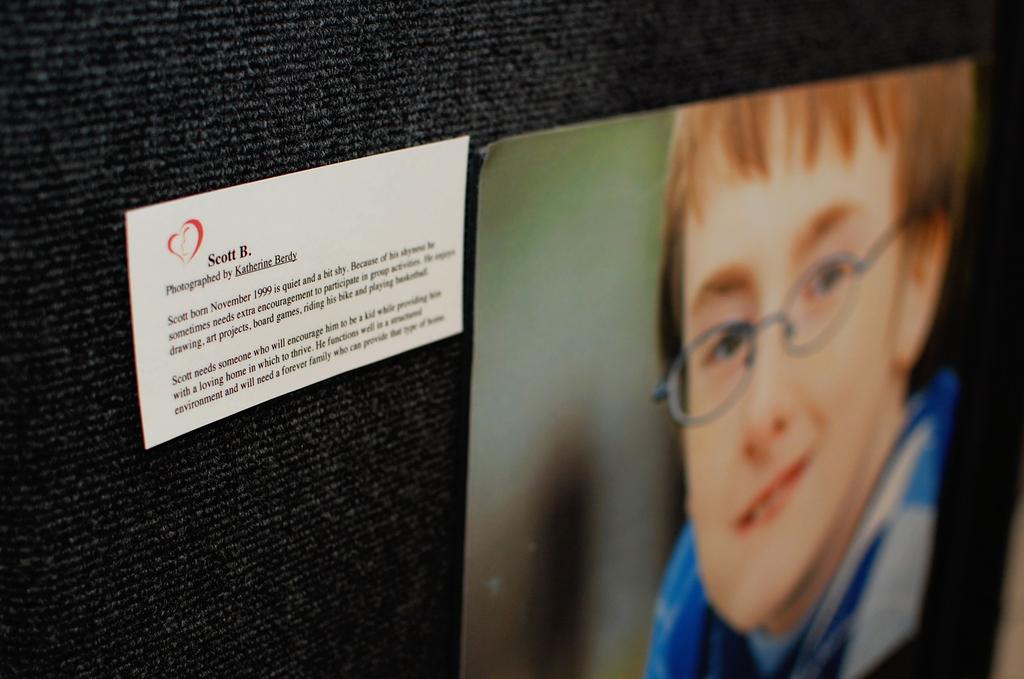Describe this image in one or two sentences. In this image, I can see a card with text and photo of a person, which are attached to a black cloth. 